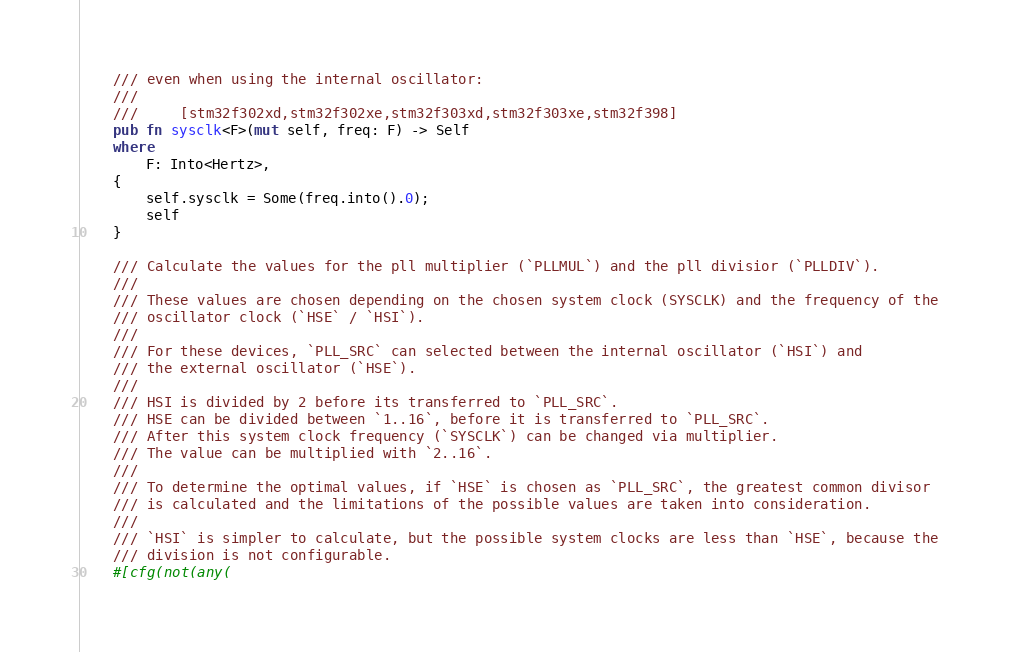Convert code to text. <code><loc_0><loc_0><loc_500><loc_500><_Rust_>    /// even when using the internal oscillator:
    ///
    ///     [stm32f302xd,stm32f302xe,stm32f303xd,stm32f303xe,stm32f398]
    pub fn sysclk<F>(mut self, freq: F) -> Self
    where
        F: Into<Hertz>,
    {
        self.sysclk = Some(freq.into().0);
        self
    }

    /// Calculate the values for the pll multiplier (`PLLMUL`) and the pll divisior (`PLLDIV`).
    ///
    /// These values are chosen depending on the chosen system clock (SYSCLK) and the frequency of the
    /// oscillator clock (`HSE` / `HSI`).
    ///
    /// For these devices, `PLL_SRC` can selected between the internal oscillator (`HSI`) and
    /// the external oscillator (`HSE`).
    ///
    /// HSI is divided by 2 before its transferred to `PLL_SRC`.
    /// HSE can be divided between `1..16`, before it is transferred to `PLL_SRC`.
    /// After this system clock frequency (`SYSCLK`) can be changed via multiplier.
    /// The value can be multiplied with `2..16`.
    ///
    /// To determine the optimal values, if `HSE` is chosen as `PLL_SRC`, the greatest common divisor
    /// is calculated and the limitations of the possible values are taken into consideration.
    ///
    /// `HSI` is simpler to calculate, but the possible system clocks are less than `HSE`, because the
    /// division is not configurable.
    #[cfg(not(any(</code> 